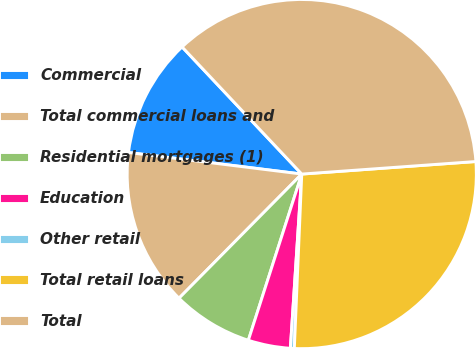Convert chart. <chart><loc_0><loc_0><loc_500><loc_500><pie_chart><fcel>Commercial<fcel>Total commercial loans and<fcel>Residential mortgages (1)<fcel>Education<fcel>Other retail<fcel>Total retail loans<fcel>Total<nl><fcel>11.01%<fcel>14.56%<fcel>7.46%<fcel>3.91%<fcel>0.36%<fcel>26.82%<fcel>35.87%<nl></chart> 